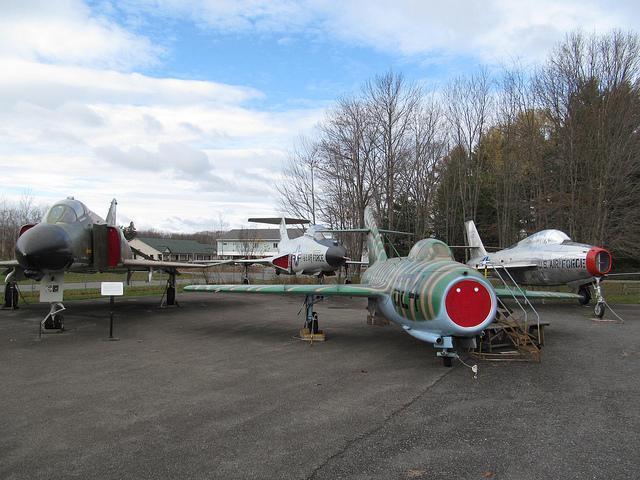The planes were likely used for what transportation purpose?
From the following set of four choices, select the accurate answer to respond to the question.
Options: Cargo, waterways, military, passenger. Military. 